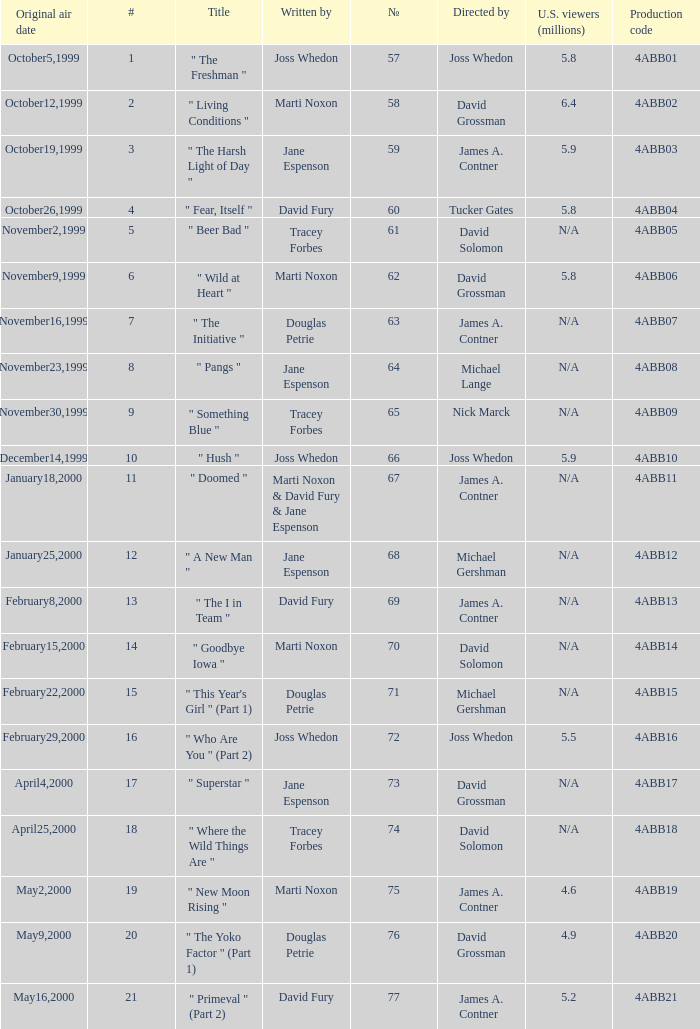Give me the full table as a dictionary. {'header': ['Original air date', '#', 'Title', 'Written by', '№', 'Directed by', 'U.S. viewers (millions)', 'Production code'], 'rows': [['October5,1999', '1', '" The Freshman "', 'Joss Whedon', '57', 'Joss Whedon', '5.8', '4ABB01'], ['October12,1999', '2', '" Living Conditions "', 'Marti Noxon', '58', 'David Grossman', '6.4', '4ABB02'], ['October19,1999', '3', '" The Harsh Light of Day "', 'Jane Espenson', '59', 'James A. Contner', '5.9', '4ABB03'], ['October26,1999', '4', '" Fear, Itself "', 'David Fury', '60', 'Tucker Gates', '5.8', '4ABB04'], ['November2,1999', '5', '" Beer Bad "', 'Tracey Forbes', '61', 'David Solomon', 'N/A', '4ABB05'], ['November9,1999', '6', '" Wild at Heart "', 'Marti Noxon', '62', 'David Grossman', '5.8', '4ABB06'], ['November16,1999', '7', '" The Initiative "', 'Douglas Petrie', '63', 'James A. Contner', 'N/A', '4ABB07'], ['November23,1999', '8', '" Pangs "', 'Jane Espenson', '64', 'Michael Lange', 'N/A', '4ABB08'], ['November30,1999', '9', '" Something Blue "', 'Tracey Forbes', '65', 'Nick Marck', 'N/A', '4ABB09'], ['December14,1999', '10', '" Hush "', 'Joss Whedon', '66', 'Joss Whedon', '5.9', '4ABB10'], ['January18,2000', '11', '" Doomed "', 'Marti Noxon & David Fury & Jane Espenson', '67', 'James A. Contner', 'N/A', '4ABB11'], ['January25,2000', '12', '" A New Man "', 'Jane Espenson', '68', 'Michael Gershman', 'N/A', '4ABB12'], ['February8,2000', '13', '" The I in Team "', 'David Fury', '69', 'James A. Contner', 'N/A', '4ABB13'], ['February15,2000', '14', '" Goodbye Iowa "', 'Marti Noxon', '70', 'David Solomon', 'N/A', '4ABB14'], ['February22,2000', '15', '" This Year\'s Girl " (Part 1)', 'Douglas Petrie', '71', 'Michael Gershman', 'N/A', '4ABB15'], ['February29,2000', '16', '" Who Are You " (Part 2)', 'Joss Whedon', '72', 'Joss Whedon', '5.5', '4ABB16'], ['April4,2000', '17', '" Superstar "', 'Jane Espenson', '73', 'David Grossman', 'N/A', '4ABB17'], ['April25,2000', '18', '" Where the Wild Things Are "', 'Tracey Forbes', '74', 'David Solomon', 'N/A', '4ABB18'], ['May2,2000', '19', '" New Moon Rising "', 'Marti Noxon', '75', 'James A. Contner', '4.6', '4ABB19'], ['May9,2000', '20', '" The Yoko Factor " (Part 1)', 'Douglas Petrie', '76', 'David Grossman', '4.9', '4ABB20'], ['May16,2000', '21', '" Primeval " (Part 2)', 'David Fury', '77', 'James A. Contner', '5.2', '4ABB21']]} What is the series No when the season 4 # is 18? 74.0. 